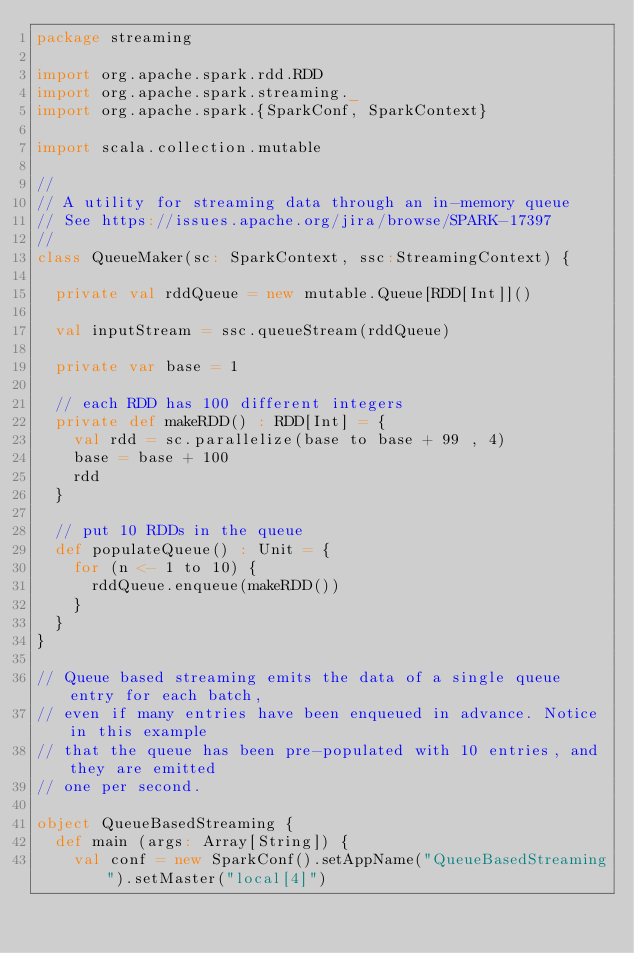Convert code to text. <code><loc_0><loc_0><loc_500><loc_500><_Scala_>package streaming

import org.apache.spark.rdd.RDD
import org.apache.spark.streaming._
import org.apache.spark.{SparkConf, SparkContext}

import scala.collection.mutable

//
// A utility for streaming data through an in-memory queue
// See https://issues.apache.org/jira/browse/SPARK-17397
//
class QueueMaker(sc: SparkContext, ssc:StreamingContext) {

  private val rddQueue = new mutable.Queue[RDD[Int]]()

  val inputStream = ssc.queueStream(rddQueue)

  private var base = 1

  // each RDD has 100 different integers
  private def makeRDD() : RDD[Int] = {
    val rdd = sc.parallelize(base to base + 99 , 4)
    base = base + 100
    rdd
  }

  // put 10 RDDs in the queue
  def populateQueue() : Unit = {
    for (n <- 1 to 10) {
      rddQueue.enqueue(makeRDD())
    }
  }
}

// Queue based streaming emits the data of a single queue entry for each batch,
// even if many entries have been enqueued in advance. Notice in this example
// that the queue has been pre-populated with 10 entries, and they are emitted
// one per second.

object QueueBasedStreaming {
  def main (args: Array[String]) {
    val conf = new SparkConf().setAppName("QueueBasedStreaming").setMaster("local[4]")</code> 